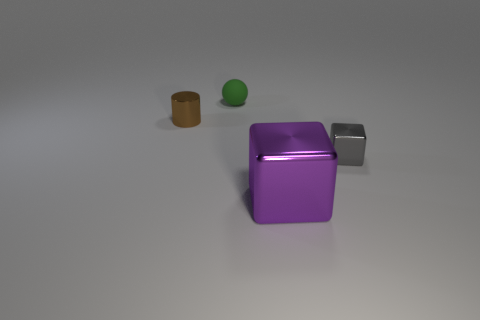Subtract all blue balls. Subtract all cyan cubes. How many balls are left? 1 Add 4 big red objects. How many objects exist? 8 Subtract all balls. How many objects are left? 3 Subtract all green rubber spheres. Subtract all yellow cylinders. How many objects are left? 3 Add 4 small metal cylinders. How many small metal cylinders are left? 5 Add 1 small shiny cylinders. How many small shiny cylinders exist? 2 Subtract 1 green balls. How many objects are left? 3 